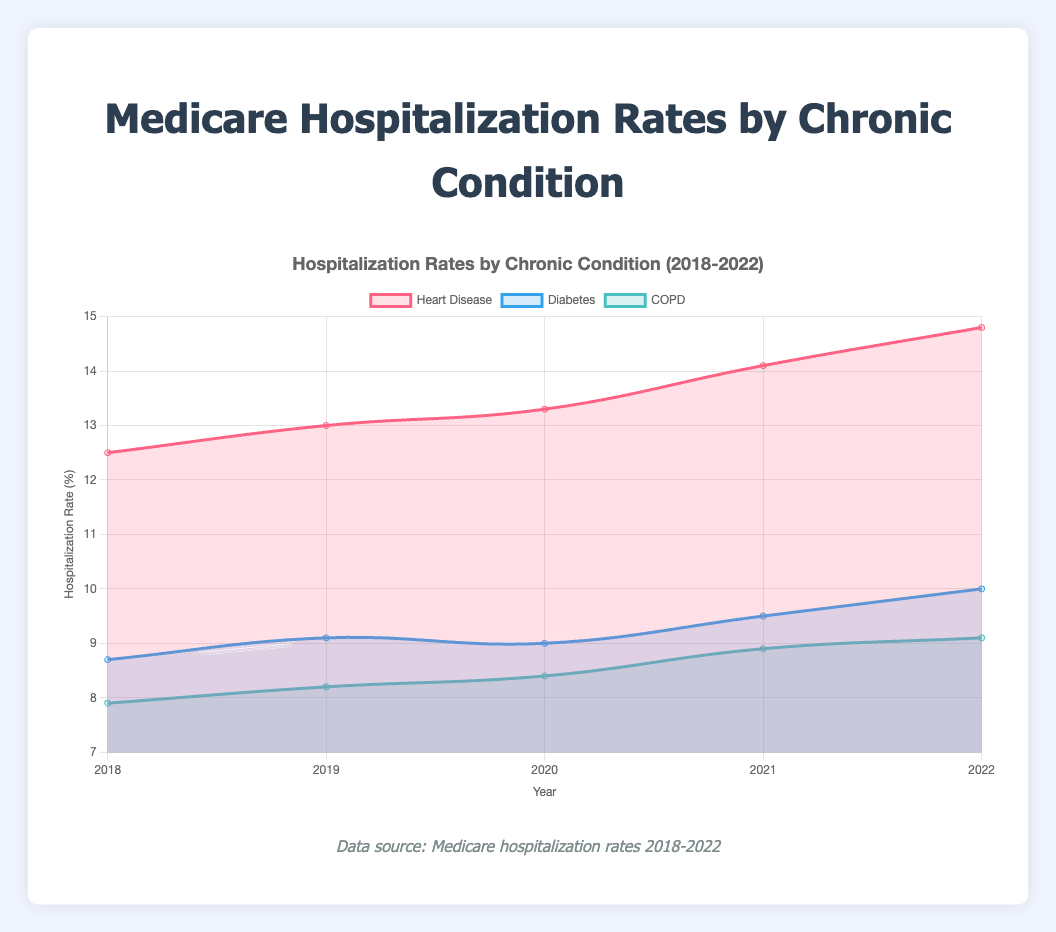What is the title of the chart? The title of the chart is located at the top and it summarizes what the chart is about. This helps in understanding the content at a glance.
Answer: Medicare Hospitalization Rates by Chronic Condition How many chronic conditions are tracked in the chart? The chart uses different colored areas to represent the various chronic conditions tracked. Count the number of unique color areas.
Answer: 3 Which chronic condition had the highest hospitalization rate in 2022? Look at the values for each condition in 2022 and identify which has the highest rate.
Answer: Heart Disease What is the trend for diabetes hospitalization rates from 2018 to 2022? Observe the diabetes area of the chart and note its direction over the years 2018 to 2022.
Answer: Increasing By how much did the hospitalization rate for Chronic Obstructive Pulmonary Disease (COPD) change from 2019 to 2020? Find the rate for COPD in 2019 and 2020, then calculate the difference.
Answer: 0.2 Which chronic condition had the smallest increase in hospitalization rates over the observed years? Compare the difference in rates from 2018 to 2022 for each condition and determine the smallest increase.
Answer: Chronic Obstructive Pulmonary Disease (COPD) Between which consecutive years did heart disease see the largest increase in hospitalization rates? Calculate the rate changes for heart disease between each pair of consecutive years, then identify the largest increase.
Answer: 2020 to 2021 How much did the hospitalization rates for diabetes increase from 2018 to 2022? Subtract the hospitalization rate for diabetes in 2018 from the rate in 2022.
Answer: 1.3% Compare the hospitalization rates of heart disease and COPD in 2021. Which was higher and by how much? Look at the rates for heart disease and COPD in 2021 and subtract COPD's rate from heart disease's rate.
Answer: Heart Disease was higher by 5.2 